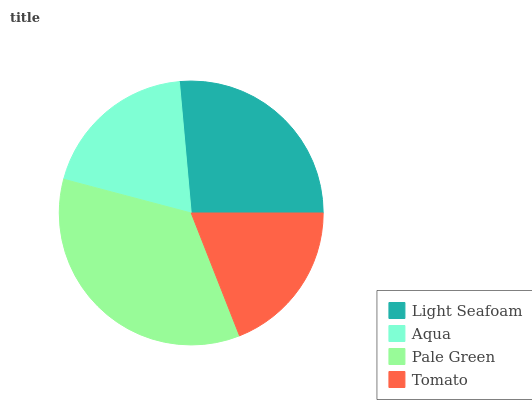Is Tomato the minimum?
Answer yes or no. Yes. Is Pale Green the maximum?
Answer yes or no. Yes. Is Aqua the minimum?
Answer yes or no. No. Is Aqua the maximum?
Answer yes or no. No. Is Light Seafoam greater than Aqua?
Answer yes or no. Yes. Is Aqua less than Light Seafoam?
Answer yes or no. Yes. Is Aqua greater than Light Seafoam?
Answer yes or no. No. Is Light Seafoam less than Aqua?
Answer yes or no. No. Is Light Seafoam the high median?
Answer yes or no. Yes. Is Aqua the low median?
Answer yes or no. Yes. Is Tomato the high median?
Answer yes or no. No. Is Light Seafoam the low median?
Answer yes or no. No. 